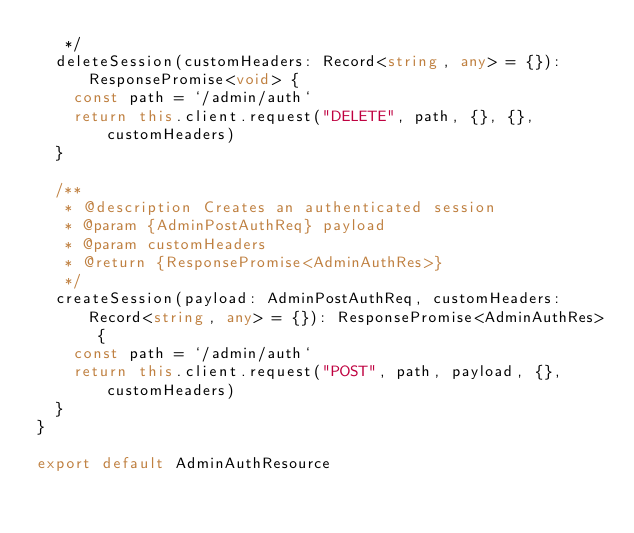<code> <loc_0><loc_0><loc_500><loc_500><_TypeScript_>   */
  deleteSession(customHeaders: Record<string, any> = {}): ResponsePromise<void> {
    const path = `/admin/auth`
    return this.client.request("DELETE", path, {}, {}, customHeaders)
  }

  /**
   * @description Creates an authenticated session
   * @param {AdminPostAuthReq} payload
   * @param customHeaders
   * @return {ResponsePromise<AdminAuthRes>}
   */
  createSession(payload: AdminPostAuthReq, customHeaders: Record<string, any> = {}): ResponsePromise<AdminAuthRes> {
    const path = `/admin/auth`
    return this.client.request("POST", path, payload, {}, customHeaders)
  }
}

export default AdminAuthResource
</code> 